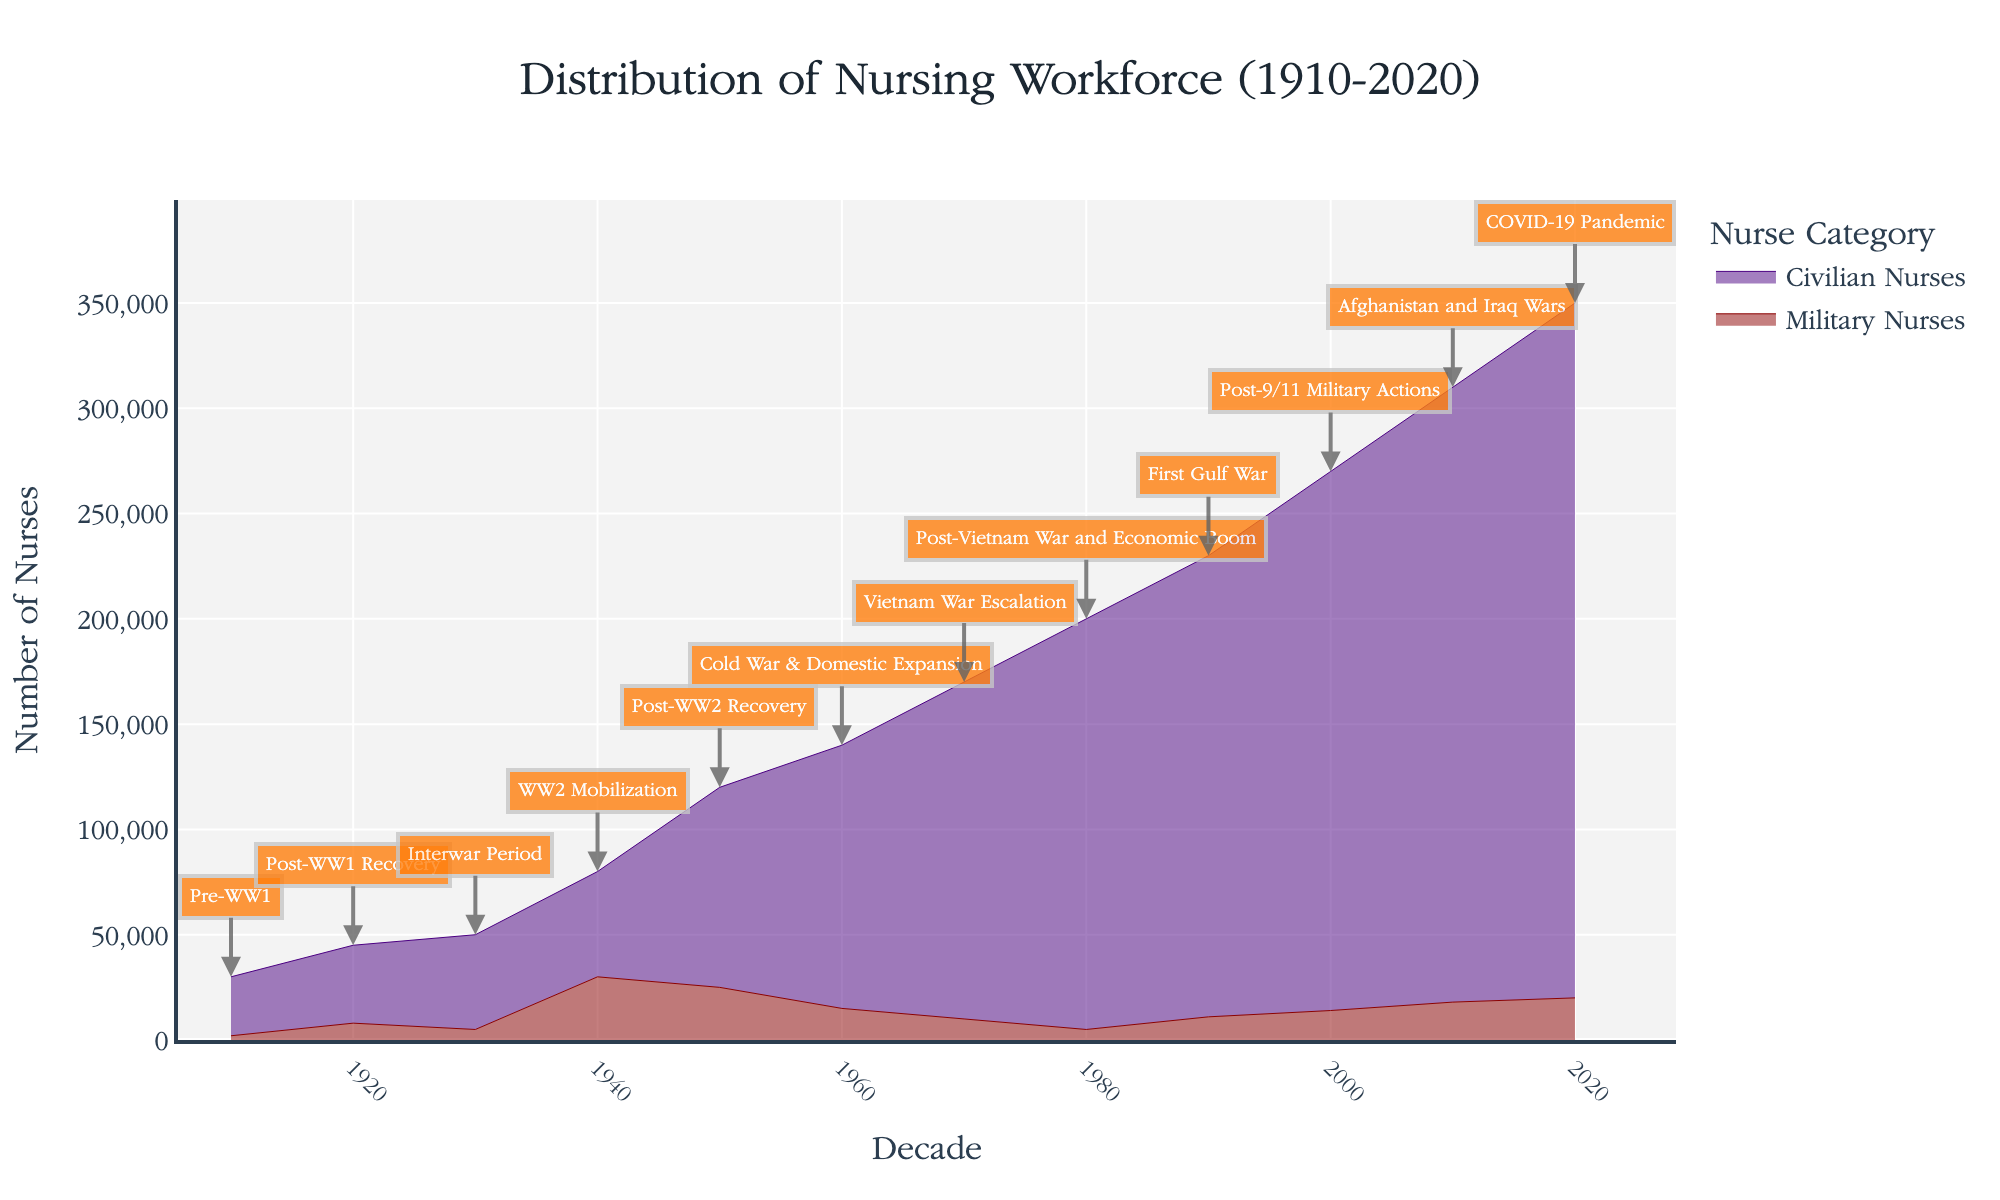What is the title of the figure? The title is usually found at the top of the chart and is meant to give a brief description of the content within the figure.
Answer: Distribution of Nursing Workforce (1910-2020) Which decade shows the highest total nursing workforce? To identify the decade with the highest total nursing workforce, look for the peak point on the y-axis where the sum of both military and civilian nurses is highest.
Answer: 2020 How did the number of civilian nurses change from 1940 to 1950? Compare the values for civilian nurses in the 1940 and 1950 columns. The number of civilian nurses increased from 50,000 in 1940 to 95,000 in 1950.
Answer: They increased Which historical event corresponds to the sharpest increase in the military nursing workforce? Examine the annotations provided for each decade and identify which event corresponds to the steepest rise in the line for military nurses. The sharpest increase occurred during WW2 Mobilization.
Answer: WW2 Mobilization How does the nursing workforce distribution during the Vietnam War compare to the Interwar Period? Compare the data points from the 1970s (Vietnam War Escalation) with the 1930s (Interwar Period) for both military and civilian nurses and total nursing workforce.
Answer: The total nursing workforce increased, with a higher proportion of civilian nurses during the Vietnam War In which decade did the number of military nurses decrease despite a worldwide conflict? Look for a decade with a conflict annotation and a decrease in the number of military nurses. During the post-WW2 recovery in the 1950s, the number of military nurses decreased despite the recent end of WW2.
Answer: 1950 What is the relationship between the workforce of civilian and military nurses in the year 2000? Compare the numbers provided for civilian and military nurses in the 2000s. Civilian nurses outnumber military nurses significantly, with 256,000 civilian nurses compared to 14,000 military nurses.
Answer: Civilian nurses significantly outnumber military nurses Identify the decade with the least number of military nurses and provide the context of the historical event. Look at the lowest point in the area representing military nurses across the decades and check the corresponding historical event annotation. The least number of military nurses appeared during the pre-WW1 era in the 1910s.
Answer: 1910, Pre-WW1 How did the total nursing workforce change during the Afghanistan and Iraq Wars? Compare the nursing workforce numbers between 2000 (Post-9/11 Military Actions) and 2010 (Afghanistan and Iraq Wars). The total nursing workforce increased from 270,000 in 2000 to 310,000 in 2010.
Answer: It increased 